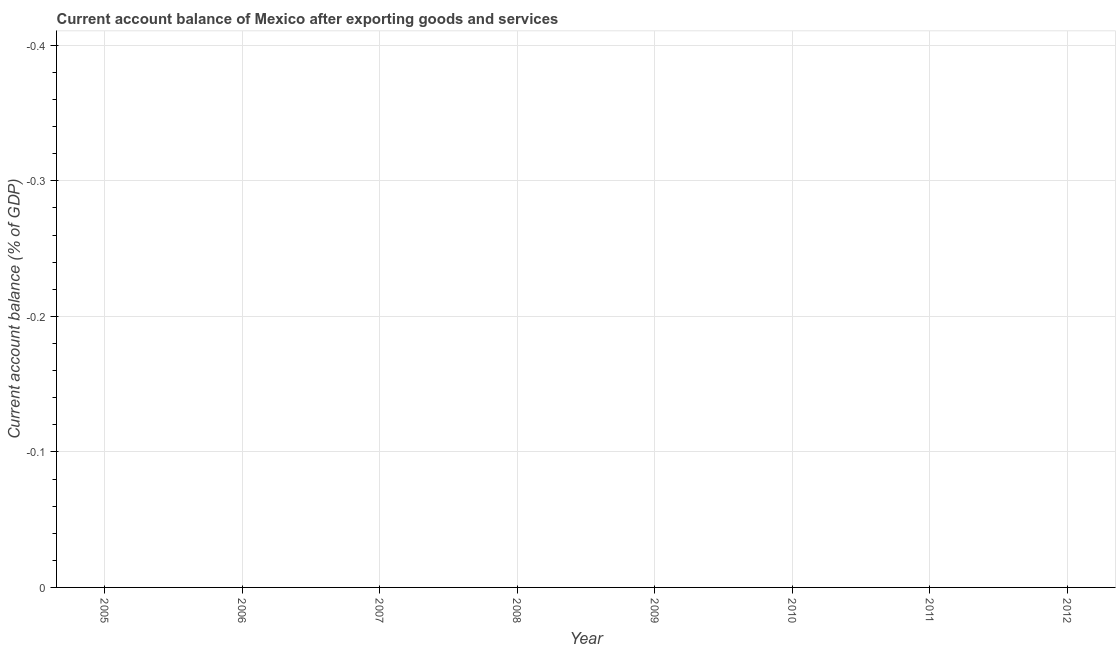What is the current account balance in 2009?
Offer a very short reply. 0. Across all years, what is the minimum current account balance?
Keep it short and to the point. 0. What is the average current account balance per year?
Make the answer very short. 0. What is the median current account balance?
Your response must be concise. 0. In how many years, is the current account balance greater than -0.30000000000000004 %?
Ensure brevity in your answer.  0. How many years are there in the graph?
Keep it short and to the point. 8. What is the difference between two consecutive major ticks on the Y-axis?
Your answer should be very brief. 0.1. Are the values on the major ticks of Y-axis written in scientific E-notation?
Keep it short and to the point. No. Does the graph contain any zero values?
Your answer should be very brief. Yes. What is the title of the graph?
Ensure brevity in your answer.  Current account balance of Mexico after exporting goods and services. What is the label or title of the Y-axis?
Provide a succinct answer. Current account balance (% of GDP). What is the Current account balance (% of GDP) in 2006?
Your response must be concise. 0. What is the Current account balance (% of GDP) of 2007?
Make the answer very short. 0. What is the Current account balance (% of GDP) of 2012?
Your answer should be compact. 0. 